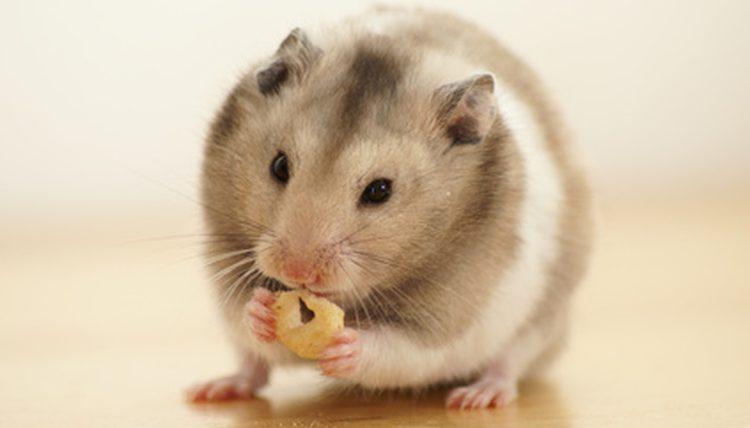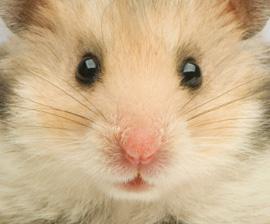The first image is the image on the left, the second image is the image on the right. Examine the images to the left and right. Is the description "A hamster is eating a piece of food." accurate? Answer yes or no. Yes. 